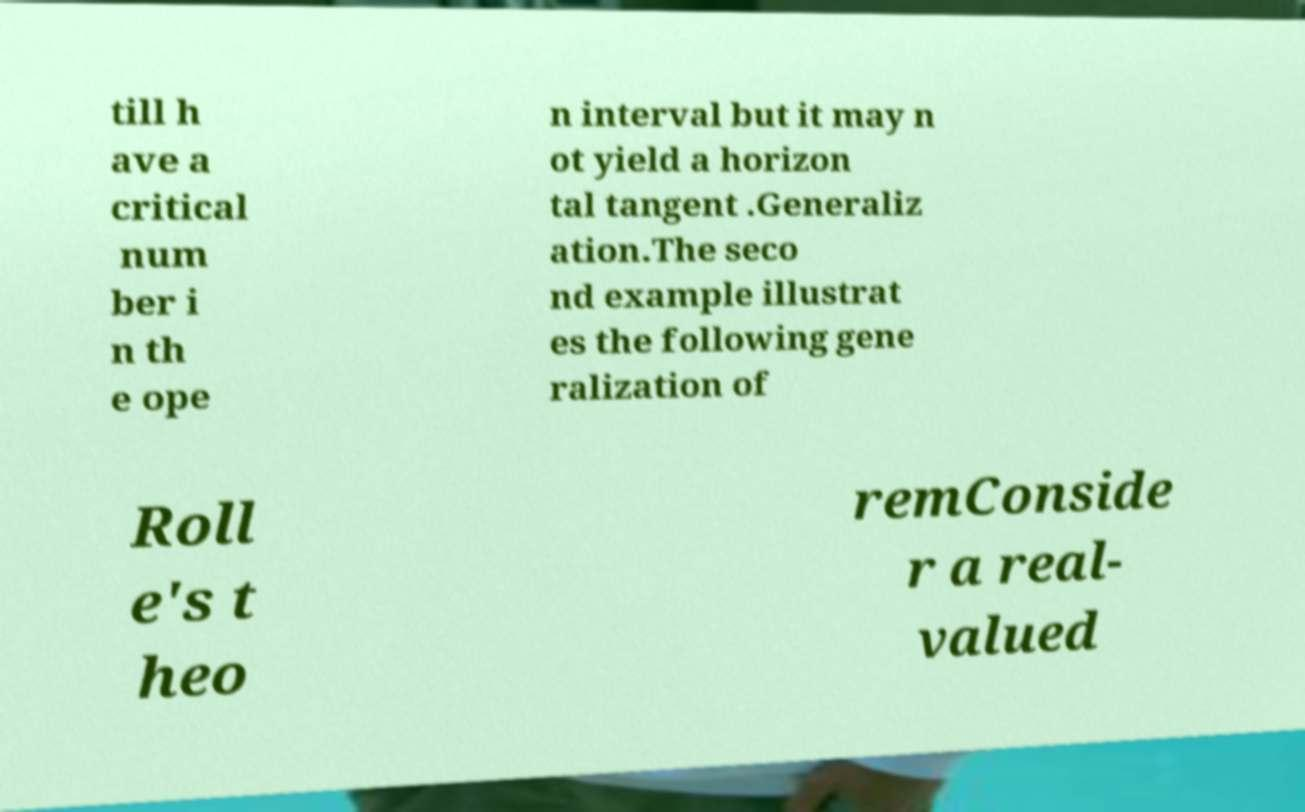Can you accurately transcribe the text from the provided image for me? till h ave a critical num ber i n th e ope n interval but it may n ot yield a horizon tal tangent .Generaliz ation.The seco nd example illustrat es the following gene ralization of Roll e's t heo remConside r a real- valued 